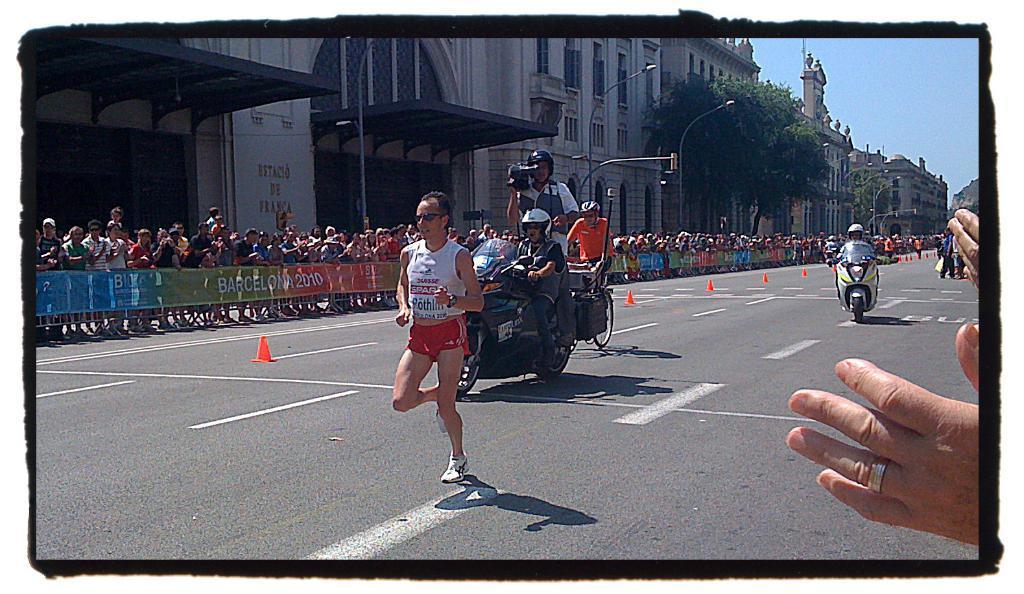Could you give a brief overview of what you see in this image? In this picture we can see a person running on the road,at back of him we can see persons riding on bikes,beside to this road we can see a fence,people,buildings,trees,poles. 